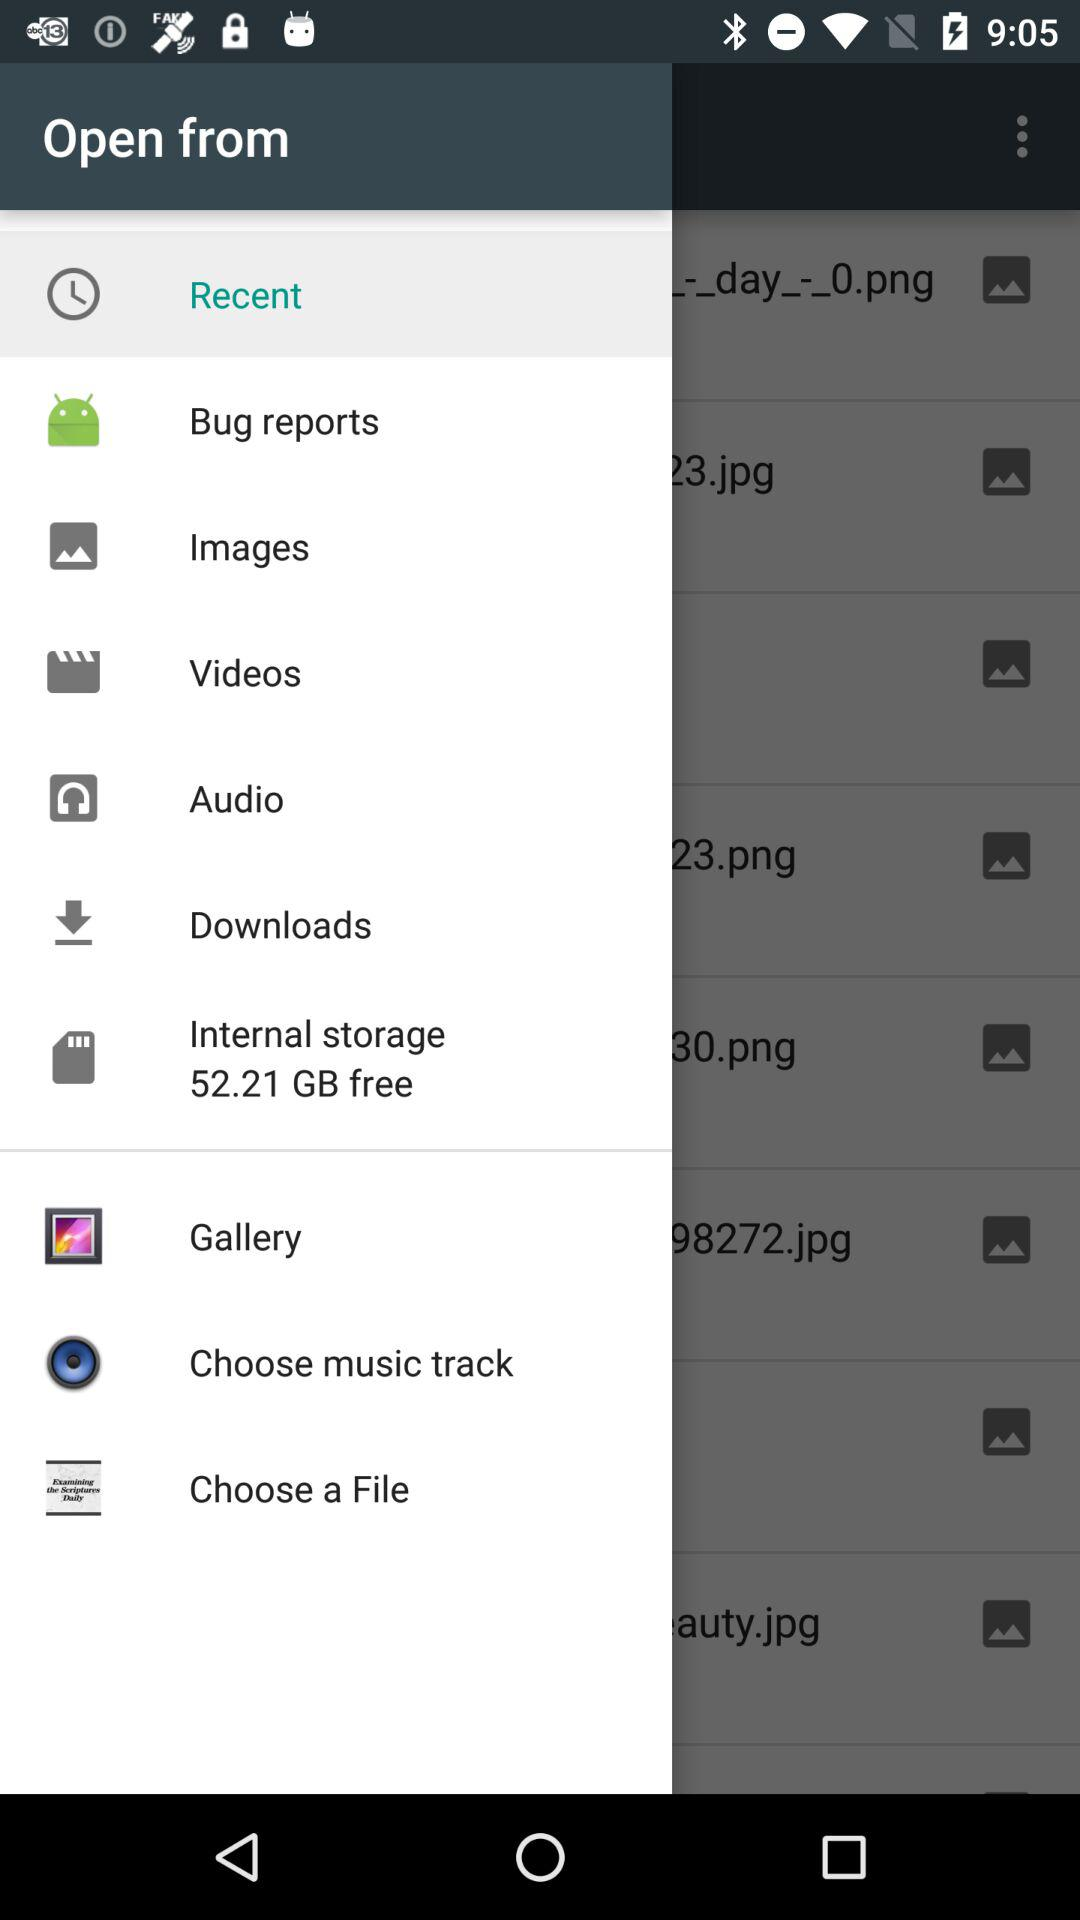Which is the selected item in the menu? The selected item is "Recent". 